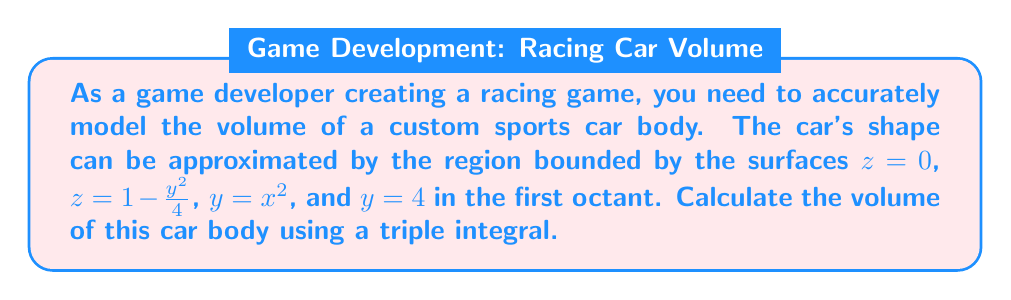Show me your answer to this math problem. To calculate the volume using a triple integral, we need to follow these steps:

1. Identify the limits of integration:
   x: From 0 to 2 (since y = x^2 and y_max = 4)
   y: From x^2 to 4
   z: From 0 to 1 - y^2/4

2. Set up the triple integral:
   $$V = \int_0^2 \int_{x^2}^4 \int_0^{1-\frac{y^2}{4}} dz \, dy \, dx$$

3. Evaluate the innermost integral (with respect to z):
   $$V = \int_0^2 \int_{x^2}^4 \left[z\right]_0^{1-\frac{y^2}{4}} dy \, dx$$
   $$V = \int_0^2 \int_{x^2}^4 \left(1-\frac{y^2}{4}\right) dy \, dx$$

4. Evaluate the middle integral (with respect to y):
   $$V = \int_0^2 \left[y - \frac{y^3}{12}\right]_{x^2}^4 dx$$
   $$V = \int_0^2 \left(4 - \frac{4^3}{12} - x^2 + \frac{x^6}{12}\right) dx$$
   $$V = \int_0^2 \left(4 - \frac{64}{12} - x^2 + \frac{x^6}{12}\right) dx$$

5. Evaluate the outermost integral (with respect to x):
   $$V = \left[4x - \frac{64}{12}x - \frac{x^3}{3} + \frac{x^7}{84}\right]_0^2$$
   $$V = \left(8 - \frac{128}{12} - \frac{8}{3} + \frac{128}{84}\right) - \left(0 - 0 - 0 + 0\right)$$
   $$V = 8 - \frac{32}{3} - \frac{8}{3} + \frac{32}{21}$$

6. Simplify the result:
   $$V = \frac{168}{21} - \frac{224}{21} - \frac{56}{21} + \frac{32}{21}$$
   $$V = \frac{168 - 224 - 56 + 32}{21} = \frac{-80}{21}$$

Therefore, the volume of the car body is $\frac{80}{21}$ cubic units.
Answer: $\frac{80}{21}$ cubic units 